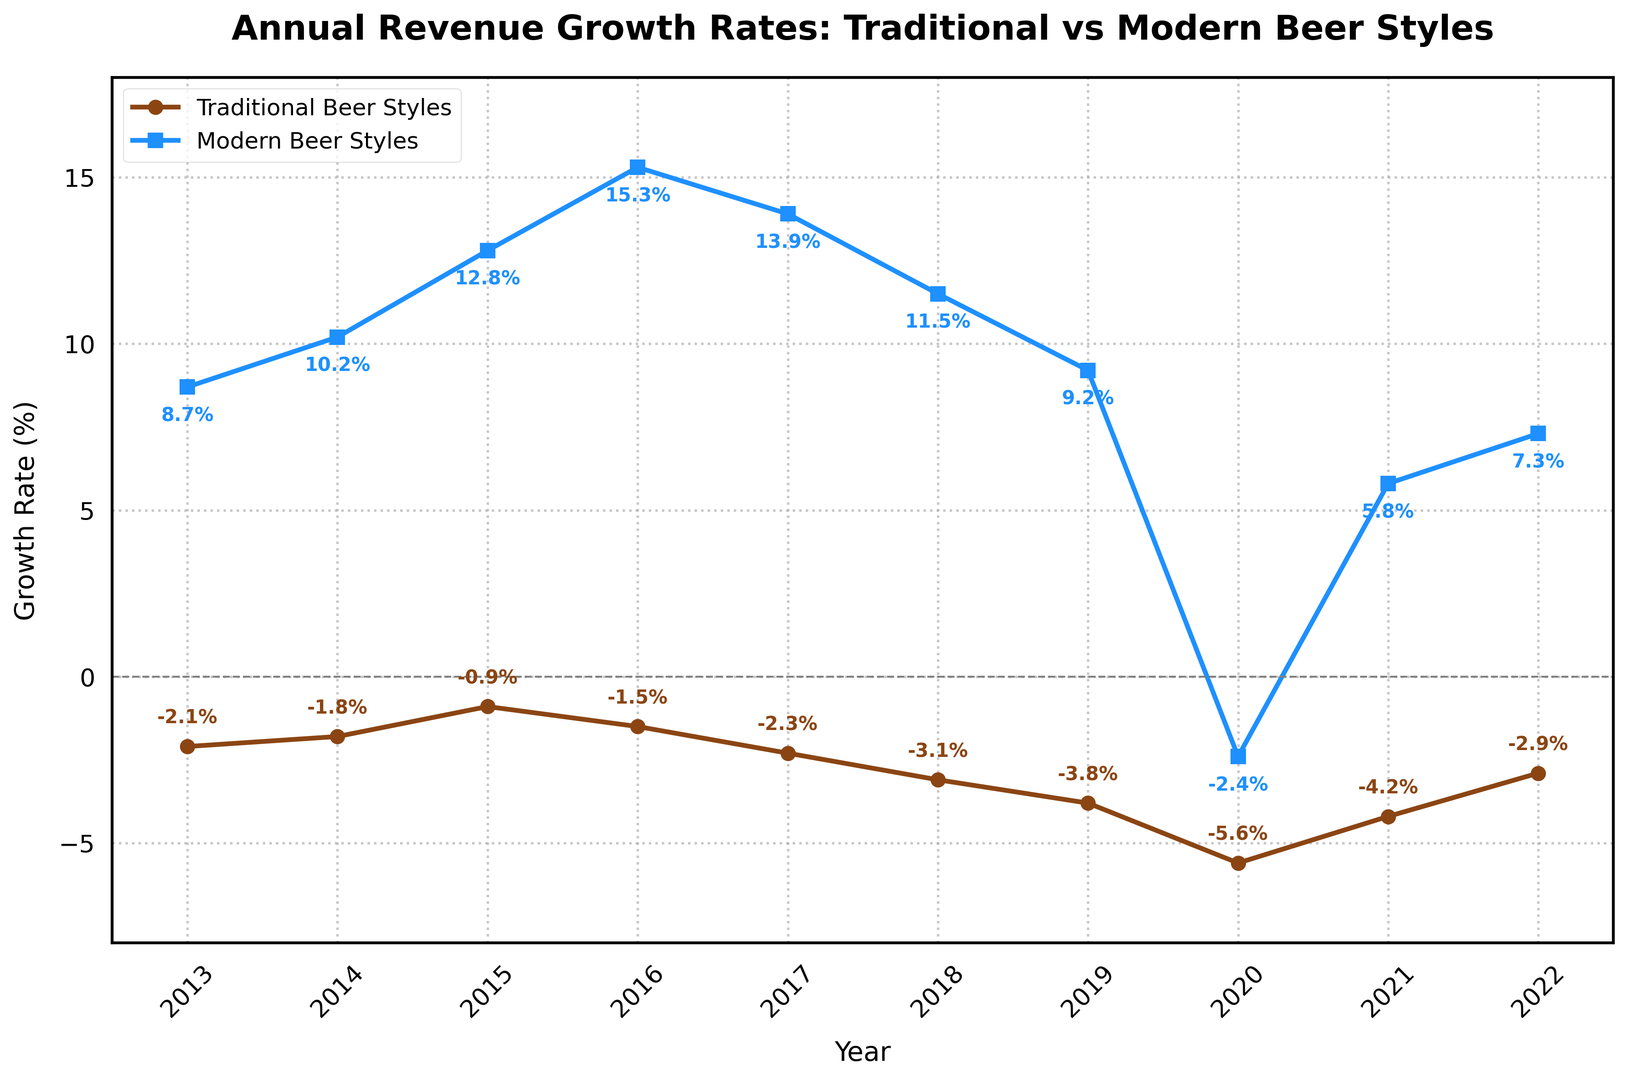What's the average revenue growth rate for Modern Beer Styles over the entire period? First, sum the percentage growth rates for Modern Beer Styles from 2013 to 2022: 8.7 + 10.2 + 12.8 + 15.3 + 13.9 + 11.5 + 9.2 + (-2.4) + 5.8 + 7.3 = 92.3. Divide this sum by the number of years (10) to find the average: 92.3 / 10 = 9.23
Answer: 9.23% How did the revenue growth rates for Traditional Beer Styles compare between 2013 and 2020? Note the values for Traditional Beer Styles in 2013 and 2020: -2.1% and -5.6%, respectively. Comparing these, the rate decreased from -2.1% in 2013 to -5.6% in 2020. Therefore, the growth rate declined.
Answer: Declined Which year had the highest revenue growth rate for Modern Beer Styles, and what was the rate? By examining the data, 2016 had the highest growth rate for Modern Beer Styles with a rate of 15.3%.
Answer: 2016, 15.3% In which years did Traditional Beer Styles experience a negative revenue growth rate? Traditional Beer Styles experienced negative growth rates in all the given years: 2013, 2014, 2015, 2016, 2017, 2018, 2019, 2020, 2021, and 2022.
Answer: 2013-2022 What is the difference in revenue growth rates for Modern Beer Styles between 2015 and 2020? In 2015, the growth rate for Modern Beer Styles was 12.8%, and in 2020 it was -2.4%. The difference is 12.8 - (-2.4) = 15.2.
Answer: 15.2 Which beer style had an overall positive trend in revenue growth over the decade? By comparing the trends, Modern Beer Styles had an overall positive trend, starting at 8.7% in 2013 and experiencing mostly positive growth rates except in 2020.
Answer: Modern Beer Styles What was the average growth rate difference between Traditional and Modern Beer Styles over the decade? Calculate the difference for each year and then find the average. For each year: (8.7-(-2.1)), (10.2-(-1.8)), (12.8-(-0.9)), (15.3-(-1.5)), (13.9-(-2.3)), (11.5-(-3.1)), (9.2-(-3.8)), (-2.4-(-5.6)), (5.8-(-4.2)), (7.3-(-2.9)). Sum these differences: 10.8 + 12.0 + 13.7 + 16.8 + 16.2 + 14.6 + 13.0 + 3.2 + 10.0 + 10.2 = 120.5. Then average: 120.5 / 10 = 12.05.
Answer: 12.05 In which year did Modern Beer Styles experience a decline in revenue growth rate? Modern Beer Styles experienced a decline in 2020, with a growth rate of -2.4%.
Answer: 2020 Which beer style had the steepest drop in revenue growth rate in any single year, and what was the drop? Traditional Beer Styles had the steepest drop between 2019 and 2020, from -3.8% to -5.6%, a drop of 1.8 percentage points.
Answer: Traditional Beer Styles, 1.8% 